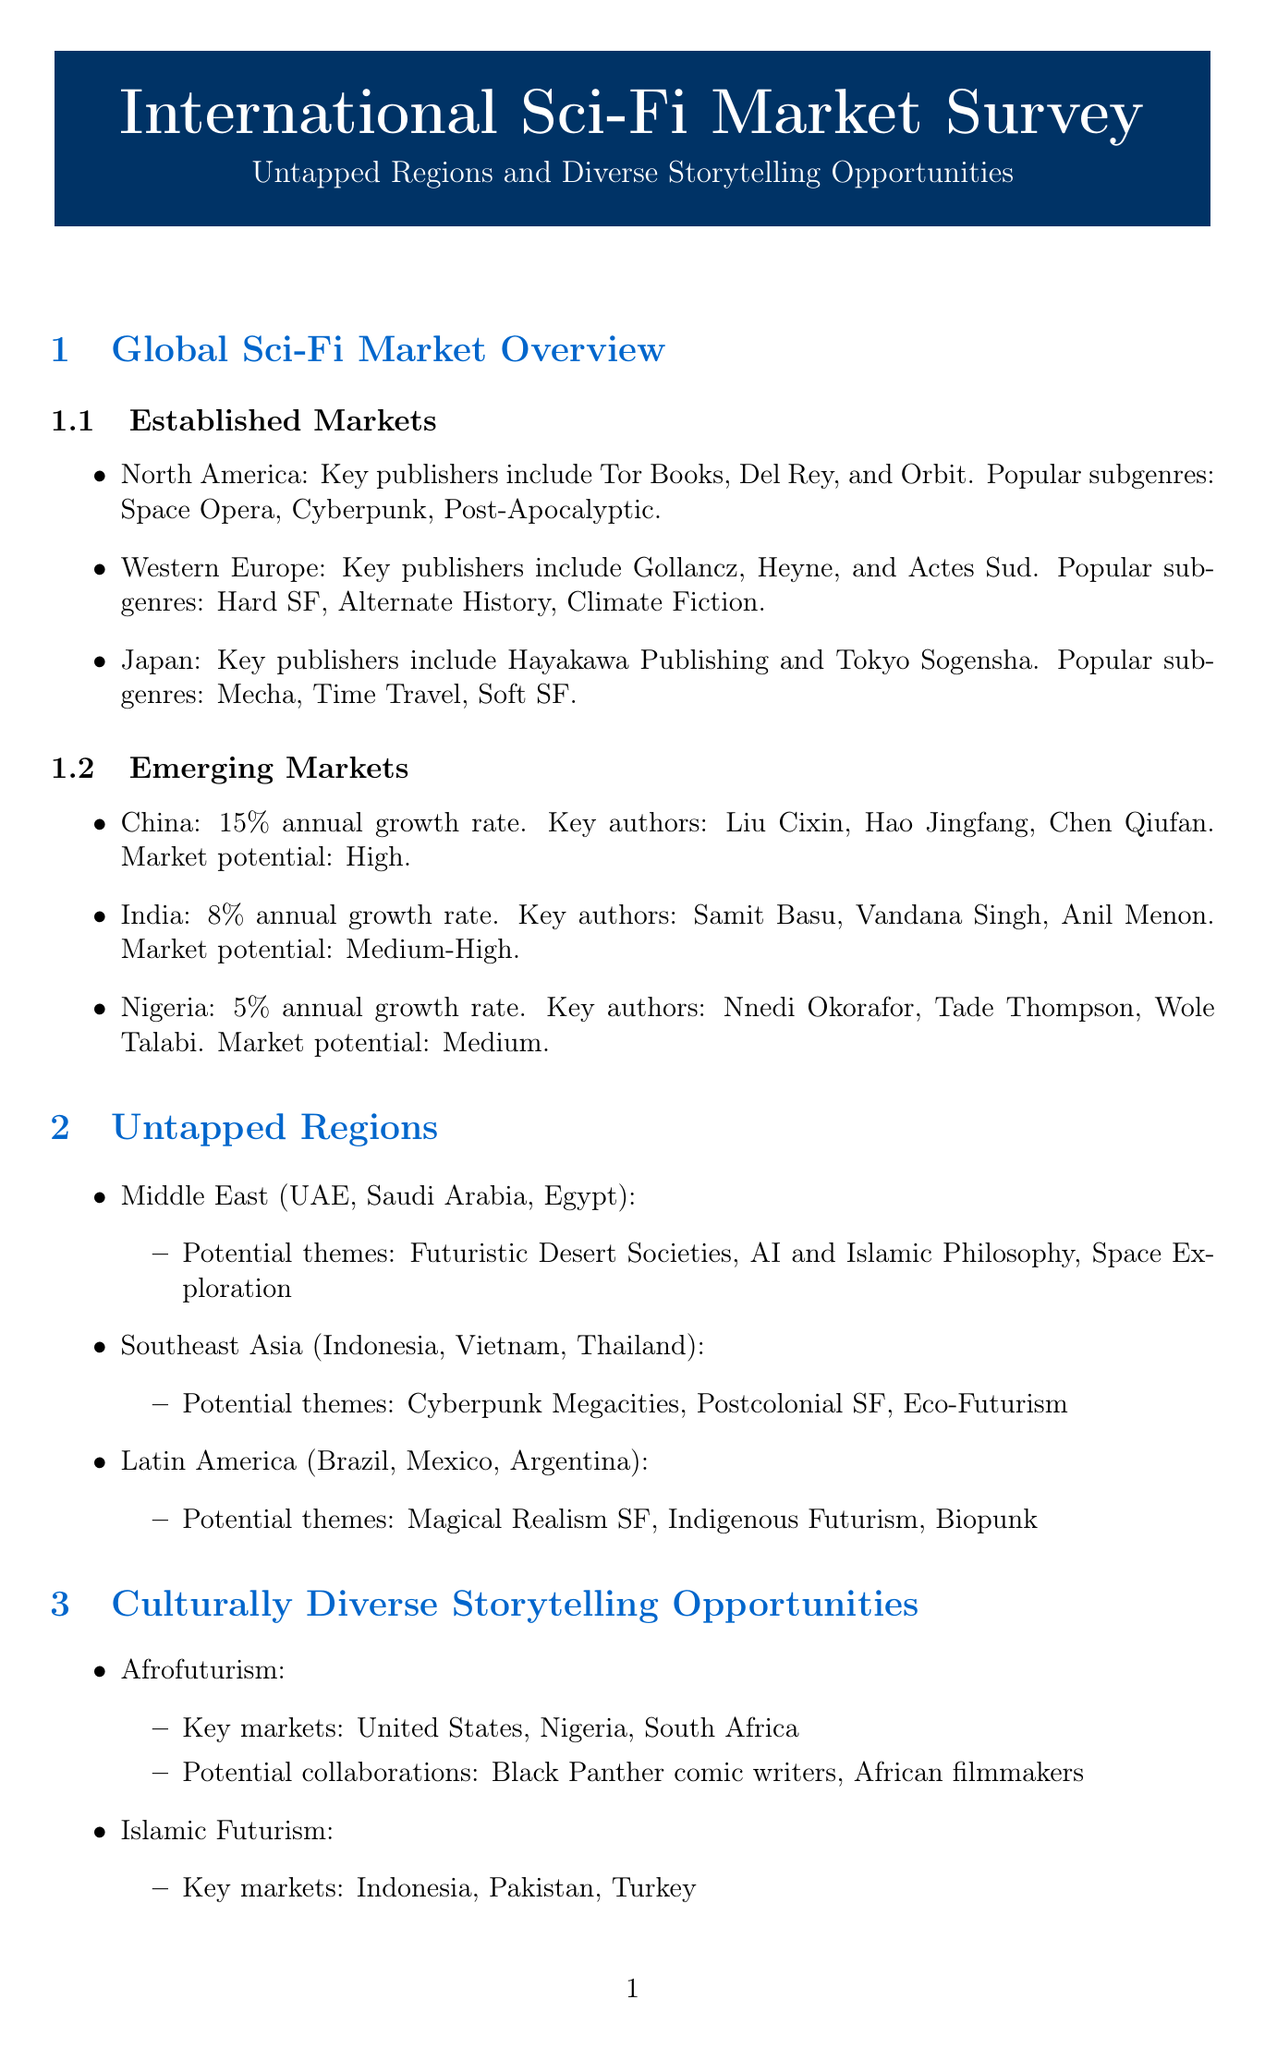What are the popular subgenres in North America? The document lists popular subgenres for North America as Space Opera, Cyberpunk, and Post-Apocalyptic.
Answer: Space Opera, Cyberpunk, Post-Apocalyptic What is the annual growth rate of the Chinese sci-fi market? The document states that the growth rate for China is 15% annually.
Answer: 15% Name one key author from Nigeria. The document provides the names of key authors from Nigeria, one of them being Nnedi Okorafor.
Answer: Nnedi Okorafor What potential theme is suggested for the Middle East region? The document mentions potential themes for the Middle East, including Futuristic Desert Societies.
Answer: Futuristic Desert Societies Which medium has an example of adapting 'Neuromancer'? The document states that 'Neuromancer' by William Gibson could be adapted in graphic novels.
Answer: Graphic novels How many key markets are listed for Afrofuturism? The document lists key markets for Afrofuturism as the United States, Nigeria, and South Africa, totaling three.
Answer: Three What is a challenge in translation and localization mentioned in the document? The document lists "Cultural context" as a challenge in translation and localization.
Answer: Cultural context What is the location of the Beijing International Book Fair? The document specifies that the Beijing International Book Fair is located in Beijing, China.
Answer: Beijing, China 